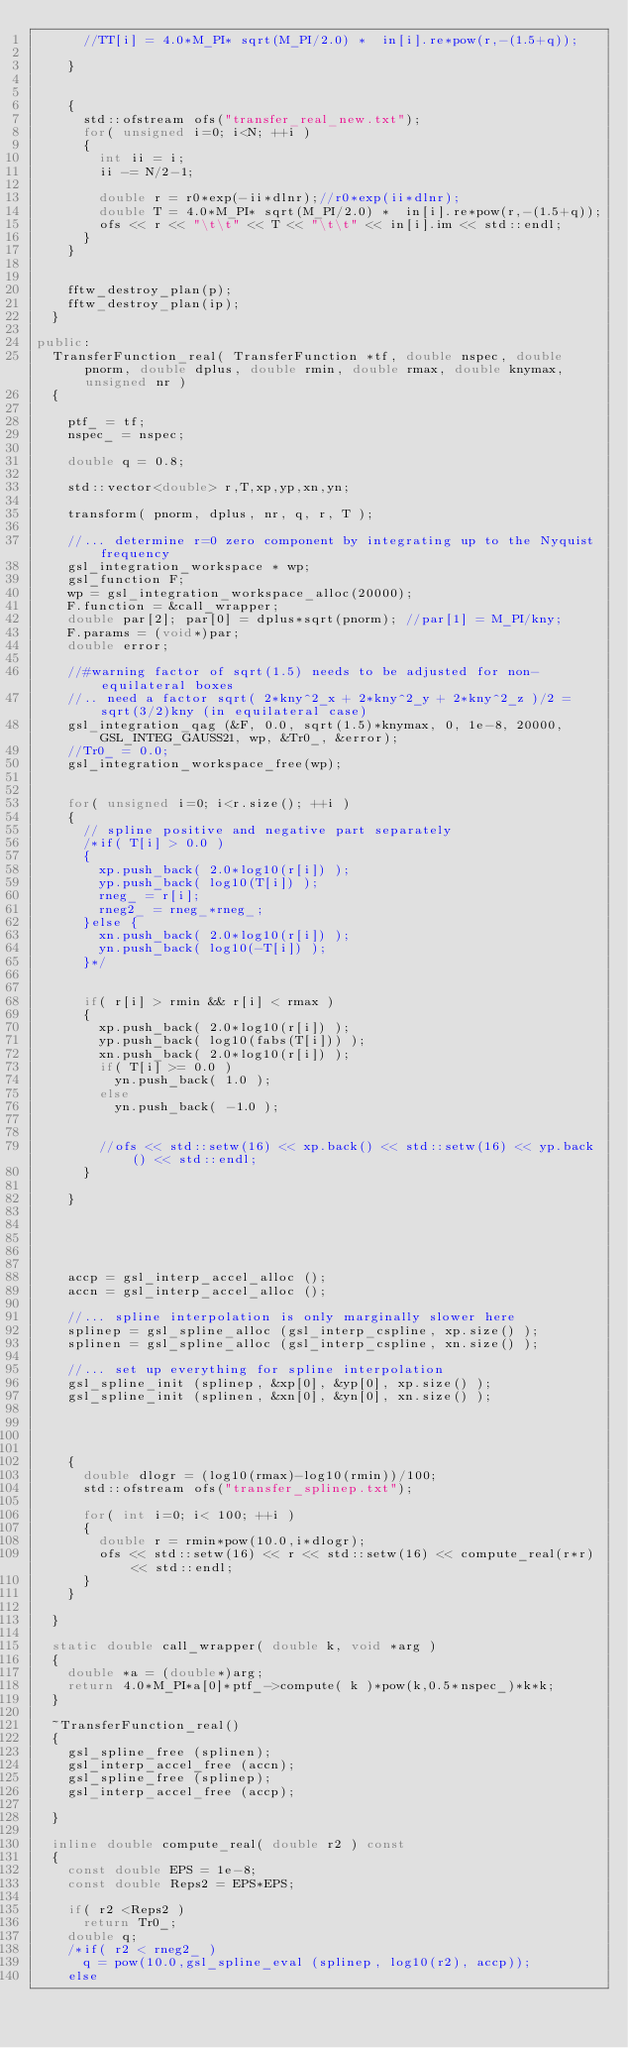<code> <loc_0><loc_0><loc_500><loc_500><_C++_>			//TT[i] = 4.0*M_PI* sqrt(M_PI/2.0) *  in[i].re*pow(r,-(1.5+q));
			
		}
		
		
		{
			std::ofstream ofs("transfer_real_new.txt");
			for( unsigned i=0; i<N; ++i )
			{
				int ii = i;
				ii -= N/2-1;
				
				double r = r0*exp(-ii*dlnr);//r0*exp(ii*dlnr);
				double T = 4.0*M_PI* sqrt(M_PI/2.0) *  in[i].re*pow(r,-(1.5+q));
				ofs << r << "\t\t" << T << "\t\t" << in[i].im << std::endl;
			}
		}
		

		fftw_destroy_plan(p);
		fftw_destroy_plan(ip);
	}
	
public:
	TransferFunction_real( TransferFunction *tf, double nspec, double pnorm, double dplus, double rmin, double rmax, double knymax, unsigned nr )
	{
				
		ptf_ = tf;
		nspec_ = nspec;
	
		double q = 0.8;
		
		std::vector<double> r,T,xp,yp,xn,yn;
		
		transform( pnorm, dplus, nr, q, r, T );
		
		//... determine r=0 zero component by integrating up to the Nyquist frequency
		gsl_integration_workspace * wp; 
		gsl_function F;
		wp = gsl_integration_workspace_alloc(20000);
		F.function = &call_wrapper;
		double par[2]; par[0] = dplus*sqrt(pnorm); //par[1] = M_PI/kny;
		F.params = (void*)par;
		double error;
		
		//#warning factor of sqrt(1.5) needs to be adjusted for non-equilateral boxes
		//.. need a factor sqrt( 2*kny^2_x + 2*kny^2_y + 2*kny^2_z )/2 = sqrt(3/2)kny (in equilateral case)
		gsl_integration_qag (&F, 0.0, sqrt(1.5)*knymax, 0, 1e-8, 20000, GSL_INTEG_GAUSS21, wp, &Tr0_, &error); 
		//Tr0_ = 0.0;
		gsl_integration_workspace_free(wp);
				
		
		for( unsigned i=0; i<r.size(); ++i )
		{
			// spline positive and negative part separately
			/*if( T[i] > 0.0 )
			{
				xp.push_back( 2.0*log10(r[i]) );
				yp.push_back( log10(T[i]) );
				rneg_ = r[i];
				rneg2_ = rneg_*rneg_;
			}else {
				xn.push_back( 2.0*log10(r[i]) );
				yn.push_back( log10(-T[i]) );
			}*/
			
			
			if( r[i] > rmin && r[i] < rmax )
			{
				xp.push_back( 2.0*log10(r[i]) );
				yp.push_back( log10(fabs(T[i])) );
				xn.push_back( 2.0*log10(r[i]) );
				if( T[i] >= 0.0 ) 
					yn.push_back( 1.0 );
				else
					yn.push_back( -1.0 );
				
				
				//ofs << std::setw(16) << xp.back() << std::setw(16) << yp.back() << std::endl;
			}
			
		}
		

		
		
		
		accp = gsl_interp_accel_alloc ();
		accn = gsl_interp_accel_alloc ();
		
		//... spline interpolation is only marginally slower here
		splinep = gsl_spline_alloc (gsl_interp_cspline, xp.size() );
		splinen = gsl_spline_alloc (gsl_interp_cspline, xn.size() );

		//... set up everything for spline interpolation
		gsl_spline_init (splinep, &xp[0], &yp[0], xp.size() );
		gsl_spline_init (splinen, &xn[0], &yn[0], xn.size() );		
		

		
		
		{
			double dlogr = (log10(rmax)-log10(rmin))/100;
			std::ofstream ofs("transfer_splinep.txt");			
			
			for( int i=0; i< 100; ++i ) 
			{
				double r = rmin*pow(10.0,i*dlogr);
				ofs << std::setw(16) << r << std::setw(16) << compute_real(r*r) << std::endl;
			}
		}
		
	}
	
	static double call_wrapper( double k, void *arg )
	{
		double *a = (double*)arg;
		return 4.0*M_PI*a[0]*ptf_->compute( k )*pow(k,0.5*nspec_)*k*k;
	}
	
	~TransferFunction_real()
	{
		gsl_spline_free (splinen);
		gsl_interp_accel_free (accn);
		gsl_spline_free (splinep);
		gsl_interp_accel_free (accp);

	}
	
	inline double compute_real( double r2 ) const
	{
		const double EPS = 1e-8;
		const double Reps2 = EPS*EPS;
		
		if( r2 <Reps2 )
			return Tr0_;
		double q;
		/*if( r2 < rneg2_ )
			q = pow(10.0,gsl_spline_eval (splinep, log10(r2), accp));
		else</code> 